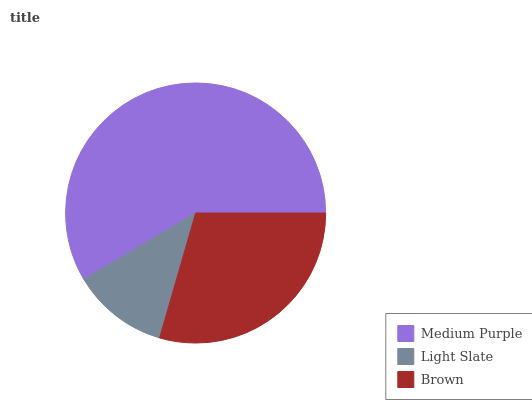Is Light Slate the minimum?
Answer yes or no. Yes. Is Medium Purple the maximum?
Answer yes or no. Yes. Is Brown the minimum?
Answer yes or no. No. Is Brown the maximum?
Answer yes or no. No. Is Brown greater than Light Slate?
Answer yes or no. Yes. Is Light Slate less than Brown?
Answer yes or no. Yes. Is Light Slate greater than Brown?
Answer yes or no. No. Is Brown less than Light Slate?
Answer yes or no. No. Is Brown the high median?
Answer yes or no. Yes. Is Brown the low median?
Answer yes or no. Yes. Is Light Slate the high median?
Answer yes or no. No. Is Light Slate the low median?
Answer yes or no. No. 